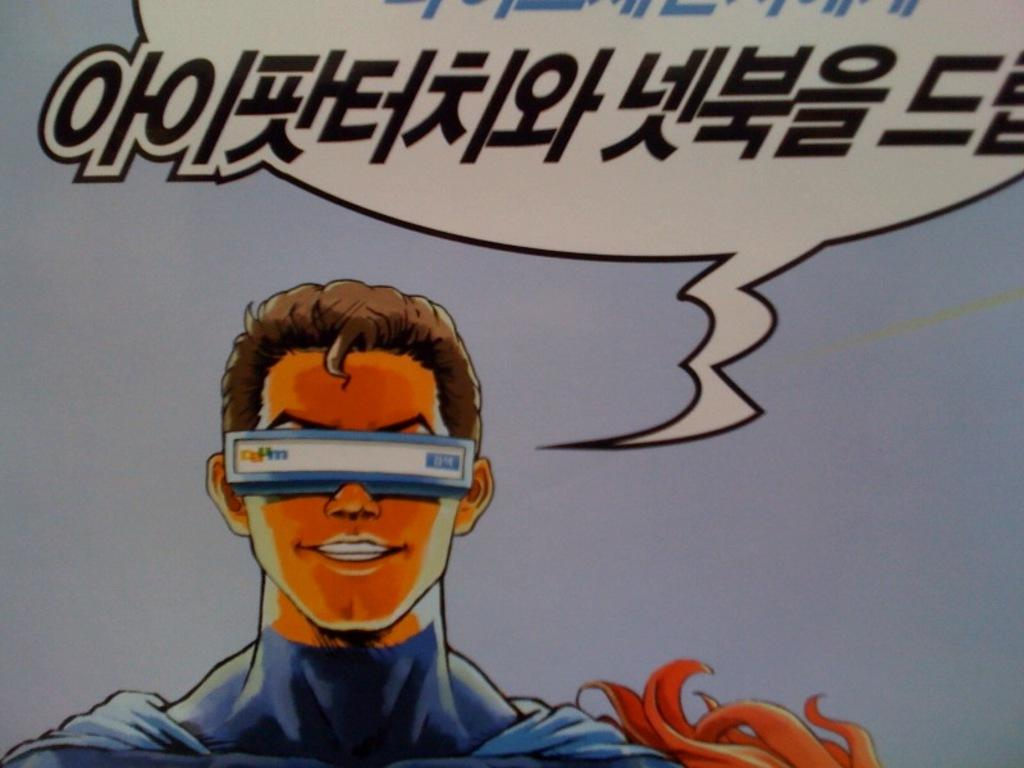What is present in the image? There is a poster in the image. What can be seen on the poster? The poster contains an image of a person. How many dimes are placed on the donkey's back in the image? There is no donkey or dimes present in the image; it only contains a poster with an image of a person. 